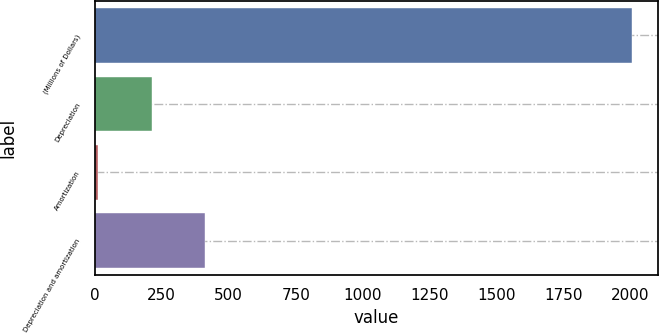Convert chart. <chart><loc_0><loc_0><loc_500><loc_500><bar_chart><fcel>(Millions of Dollars)<fcel>Depreciation<fcel>Amortization<fcel>Depreciation and amortization<nl><fcel>2004<fcel>212.1<fcel>13<fcel>411.2<nl></chart> 